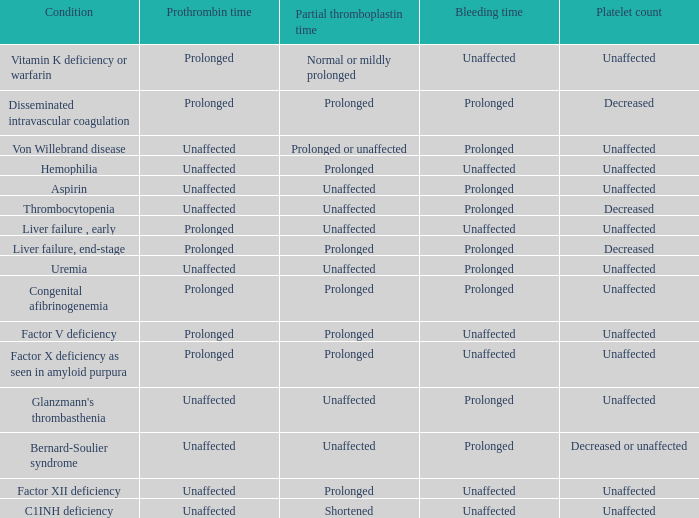Which Condition has an unaffected Prothrombin time and a Bleeding time, and a Partial thromboplastin time of prolonged? Hemophilia, Factor XII deficiency. 